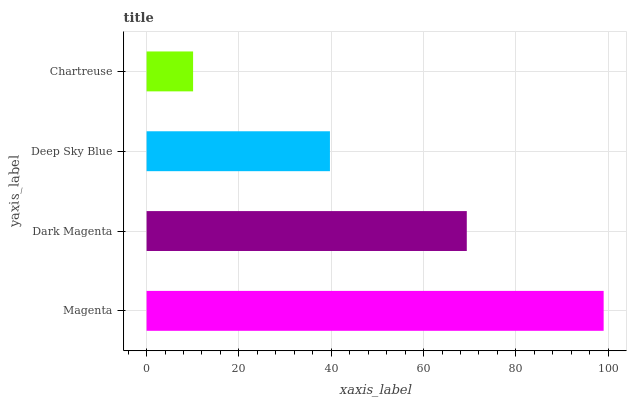Is Chartreuse the minimum?
Answer yes or no. Yes. Is Magenta the maximum?
Answer yes or no. Yes. Is Dark Magenta the minimum?
Answer yes or no. No. Is Dark Magenta the maximum?
Answer yes or no. No. Is Magenta greater than Dark Magenta?
Answer yes or no. Yes. Is Dark Magenta less than Magenta?
Answer yes or no. Yes. Is Dark Magenta greater than Magenta?
Answer yes or no. No. Is Magenta less than Dark Magenta?
Answer yes or no. No. Is Dark Magenta the high median?
Answer yes or no. Yes. Is Deep Sky Blue the low median?
Answer yes or no. Yes. Is Magenta the high median?
Answer yes or no. No. Is Dark Magenta the low median?
Answer yes or no. No. 